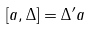<formula> <loc_0><loc_0><loc_500><loc_500>[ a , \Delta ] = \Delta ^ { \prime } a</formula> 